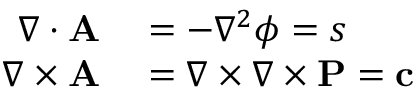<formula> <loc_0><loc_0><loc_500><loc_500>\begin{array} { r l } { \nabla \cdot A } & = - \nabla ^ { 2 } \phi = s } \\ { \nabla \times A } & = \nabla \times \nabla \times P = c } \end{array}</formula> 